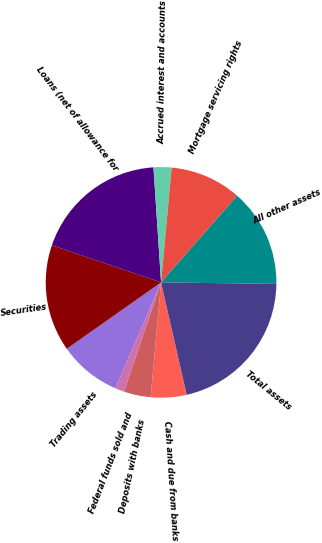Convert chart. <chart><loc_0><loc_0><loc_500><loc_500><pie_chart><fcel>Cash and due from banks<fcel>Deposits with banks<fcel>Federal funds sold and<fcel>Trading assets<fcel>Securities<fcel>Loans (net of allowance for<fcel>Accrued interest and accounts<fcel>Mortgage servicing rights<fcel>All other assets<fcel>Total assets<nl><fcel>5.01%<fcel>3.77%<fcel>1.27%<fcel>8.75%<fcel>14.99%<fcel>18.73%<fcel>2.52%<fcel>10.0%<fcel>13.74%<fcel>21.22%<nl></chart> 